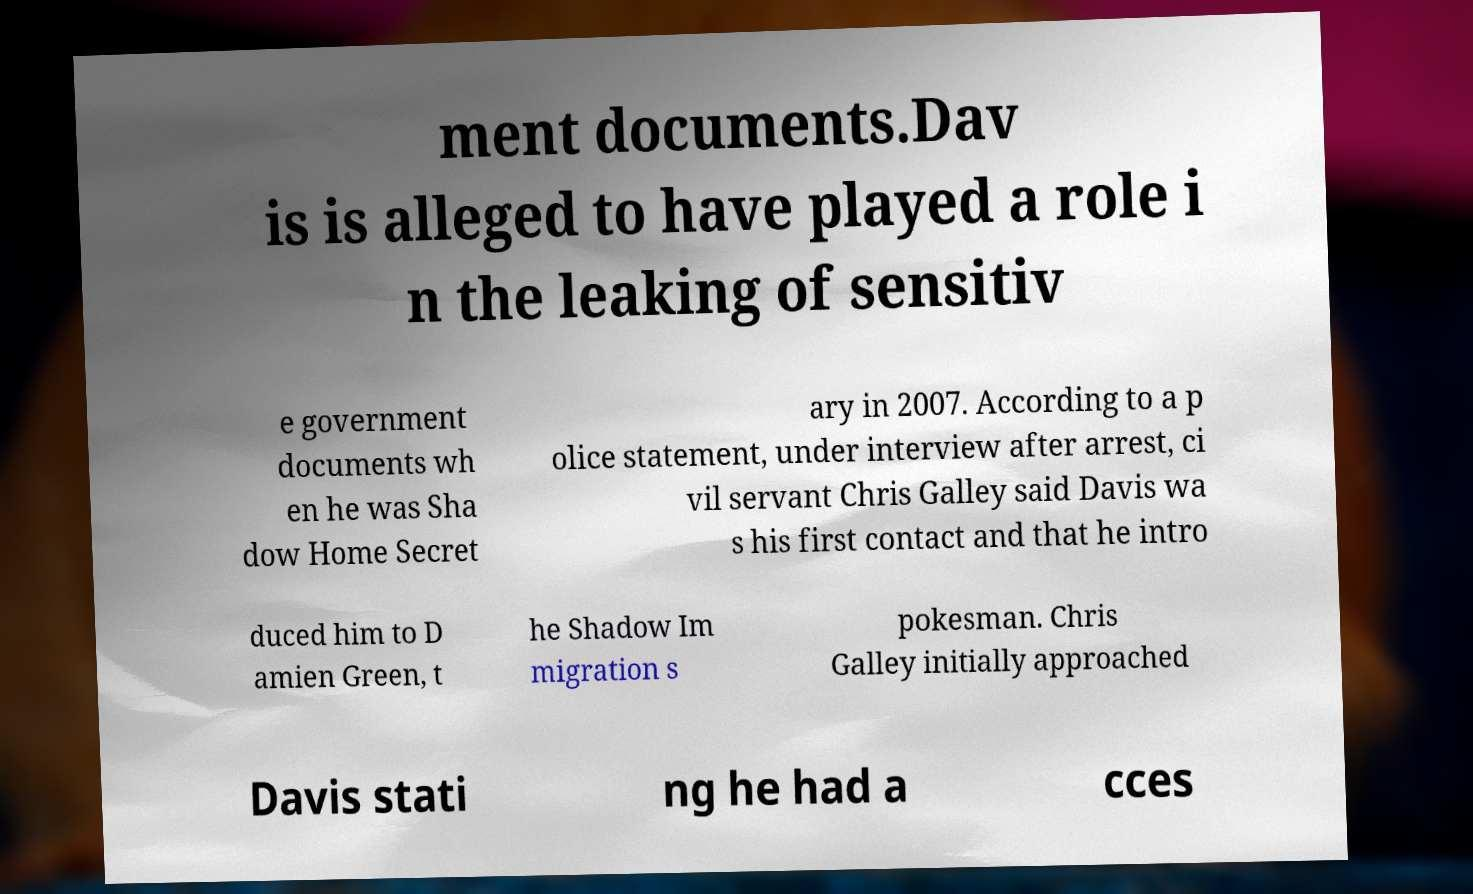Can you accurately transcribe the text from the provided image for me? ment documents.Dav is is alleged to have played a role i n the leaking of sensitiv e government documents wh en he was Sha dow Home Secret ary in 2007. According to a p olice statement, under interview after arrest, ci vil servant Chris Galley said Davis wa s his first contact and that he intro duced him to D amien Green, t he Shadow Im migration s pokesman. Chris Galley initially approached Davis stati ng he had a cces 